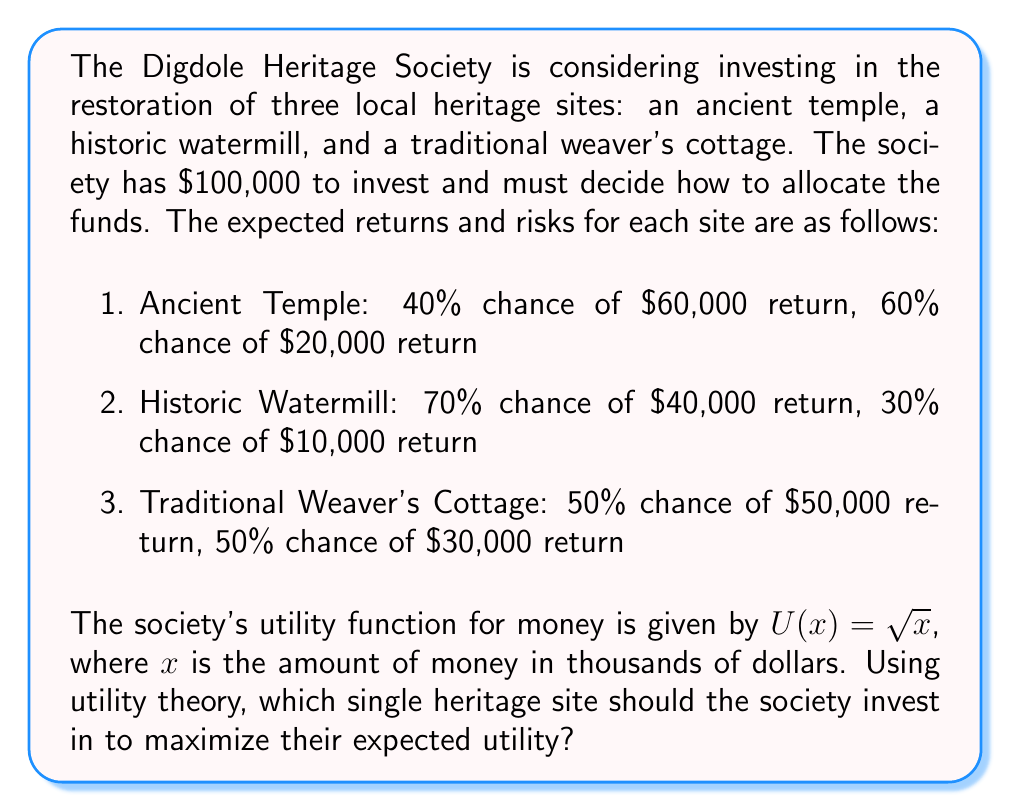Can you answer this question? To solve this problem, we need to calculate the expected utility for each investment option and choose the one with the highest value. Let's go through the process step-by-step:

1. Calculate the utility for each possible outcome:

   For the Ancient Temple:
   $U(60) = \sqrt{60} \approx 7.746$
   $U(20) = \sqrt{20} \approx 4.472$

   For the Historic Watermill:
   $U(40) = \sqrt{40} \approx 6.325$
   $U(10) = \sqrt{10} \approx 3.162$

   For the Traditional Weaver's Cottage:
   $U(50) = \sqrt{50} \approx 7.071$
   $U(30) = \sqrt{30} \approx 5.477$

2. Calculate the expected utility for each investment option:

   Ancient Temple:
   $E[U] = 0.4 \times U(60) + 0.6 \times U(20)$
   $E[U] = 0.4 \times 7.746 + 0.6 \times 4.472 \approx 5.782$

   Historic Watermill:
   $E[U] = 0.7 \times U(40) + 0.3 \times U(10)$
   $E[U] = 0.7 \times 6.325 + 0.3 \times 3.162 \approx 5.427$

   Traditional Weaver's Cottage:
   $E[U] = 0.5 \times U(50) + 0.5 \times U(30)$
   $E[U] = 0.5 \times 7.071 + 0.5 \times 5.477 \approx 6.274$

3. Compare the expected utilities:

   Ancient Temple: 5.782
   Historic Watermill: 5.427
   Traditional Weaver's Cottage: 6.274

The Traditional Weaver's Cottage has the highest expected utility, so it is the best investment choice for the Digdole Heritage Society according to utility theory.
Answer: The Digdole Heritage Society should invest in the Traditional Weaver's Cottage, as it has the highest expected utility of 6.274. 